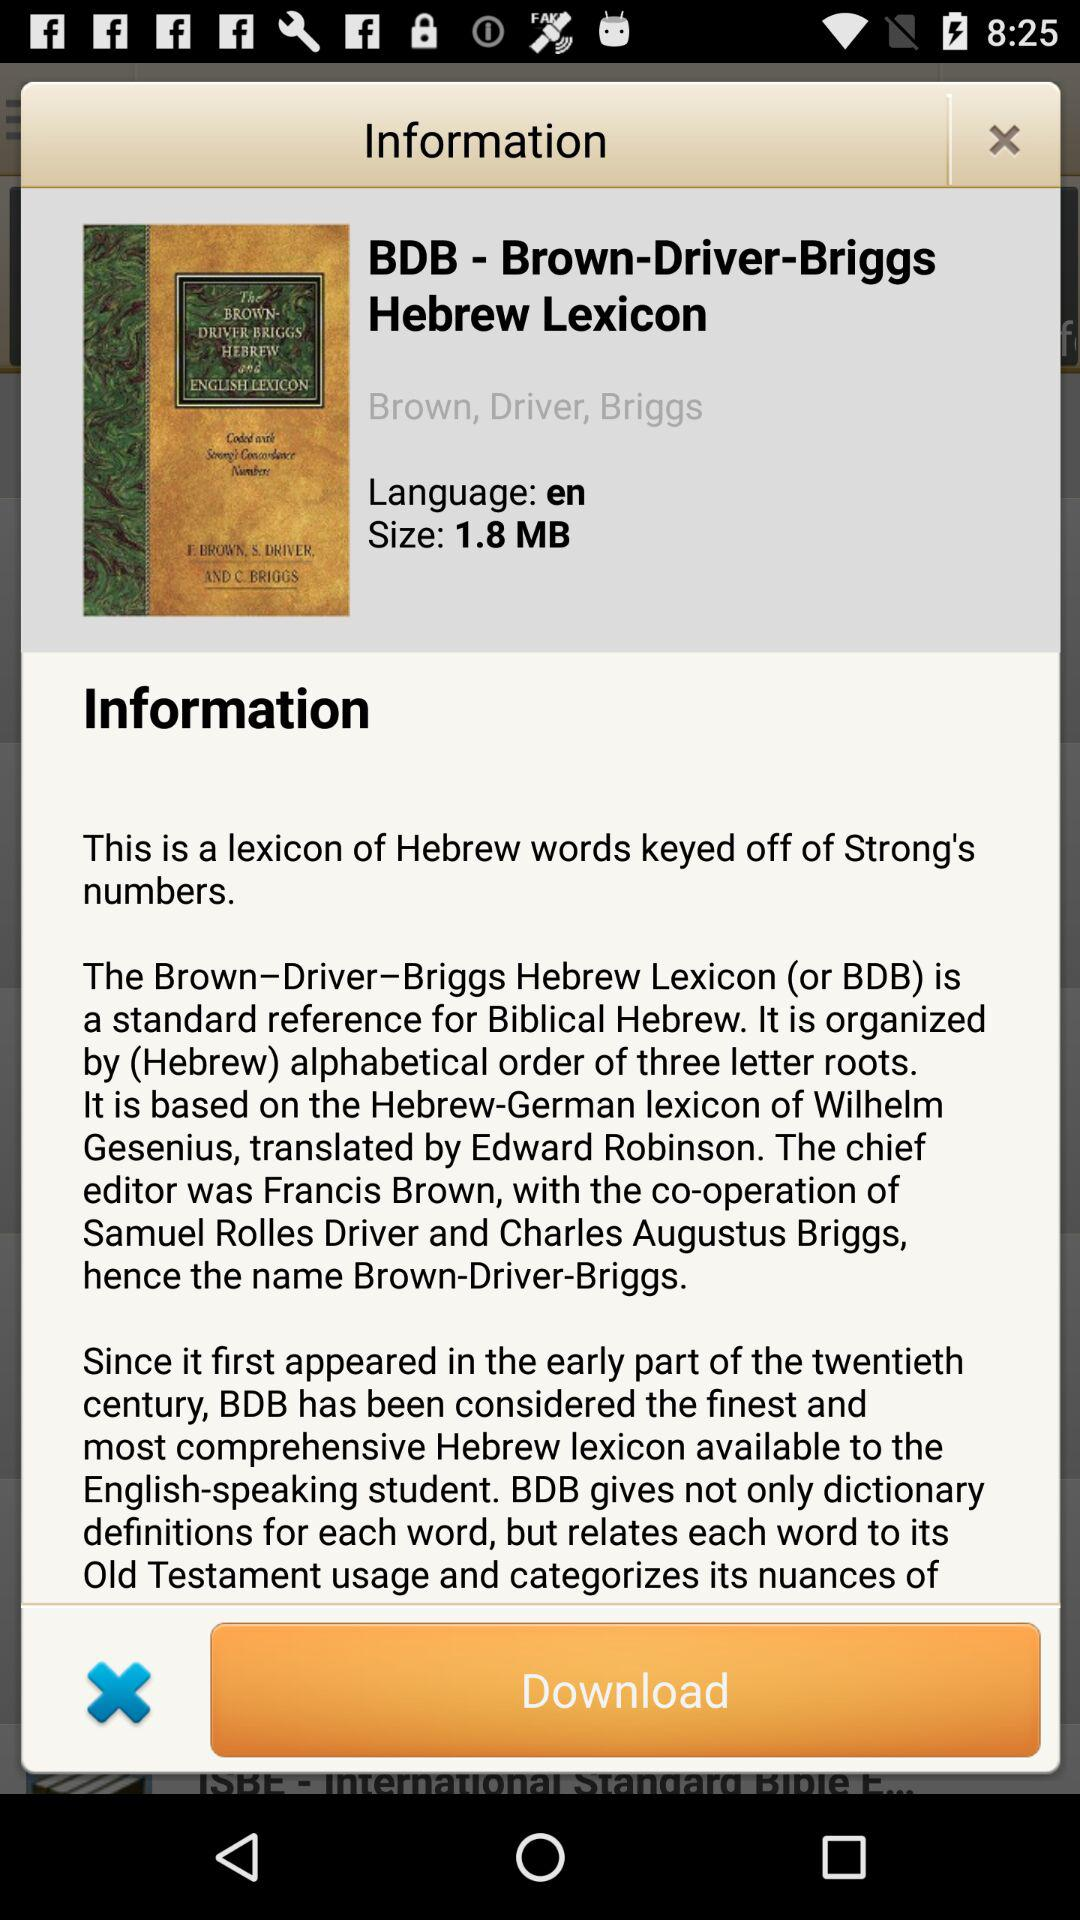What is the title of the book? The title of the book is "BDB - Brown-Driver-Briggs Hebrew Lexicon". 